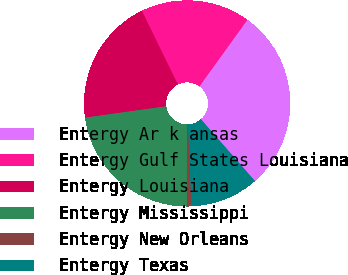<chart> <loc_0><loc_0><loc_500><loc_500><pie_chart><fcel>Entergy Ar k ansas<fcel>Entergy Gulf States Louisiana<fcel>Entergy Louisiana<fcel>Entergy Mississippi<fcel>Entergy New Orleans<fcel>Entergy Texas<nl><fcel>28.63%<fcel>17.18%<fcel>19.97%<fcel>22.76%<fcel>0.72%<fcel>10.74%<nl></chart> 